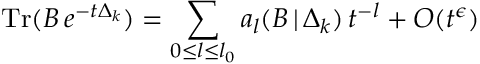Convert formula to latex. <formula><loc_0><loc_0><loc_500><loc_500>T r ( B \, e ^ { - t \Delta _ { k } } ) = \sum _ { 0 { \leq } l { \leq } l _ { 0 } } a _ { l } ( B \, | \, \Delta _ { k } ) \, t ^ { - l } + O ( t ^ { \epsilon } )</formula> 